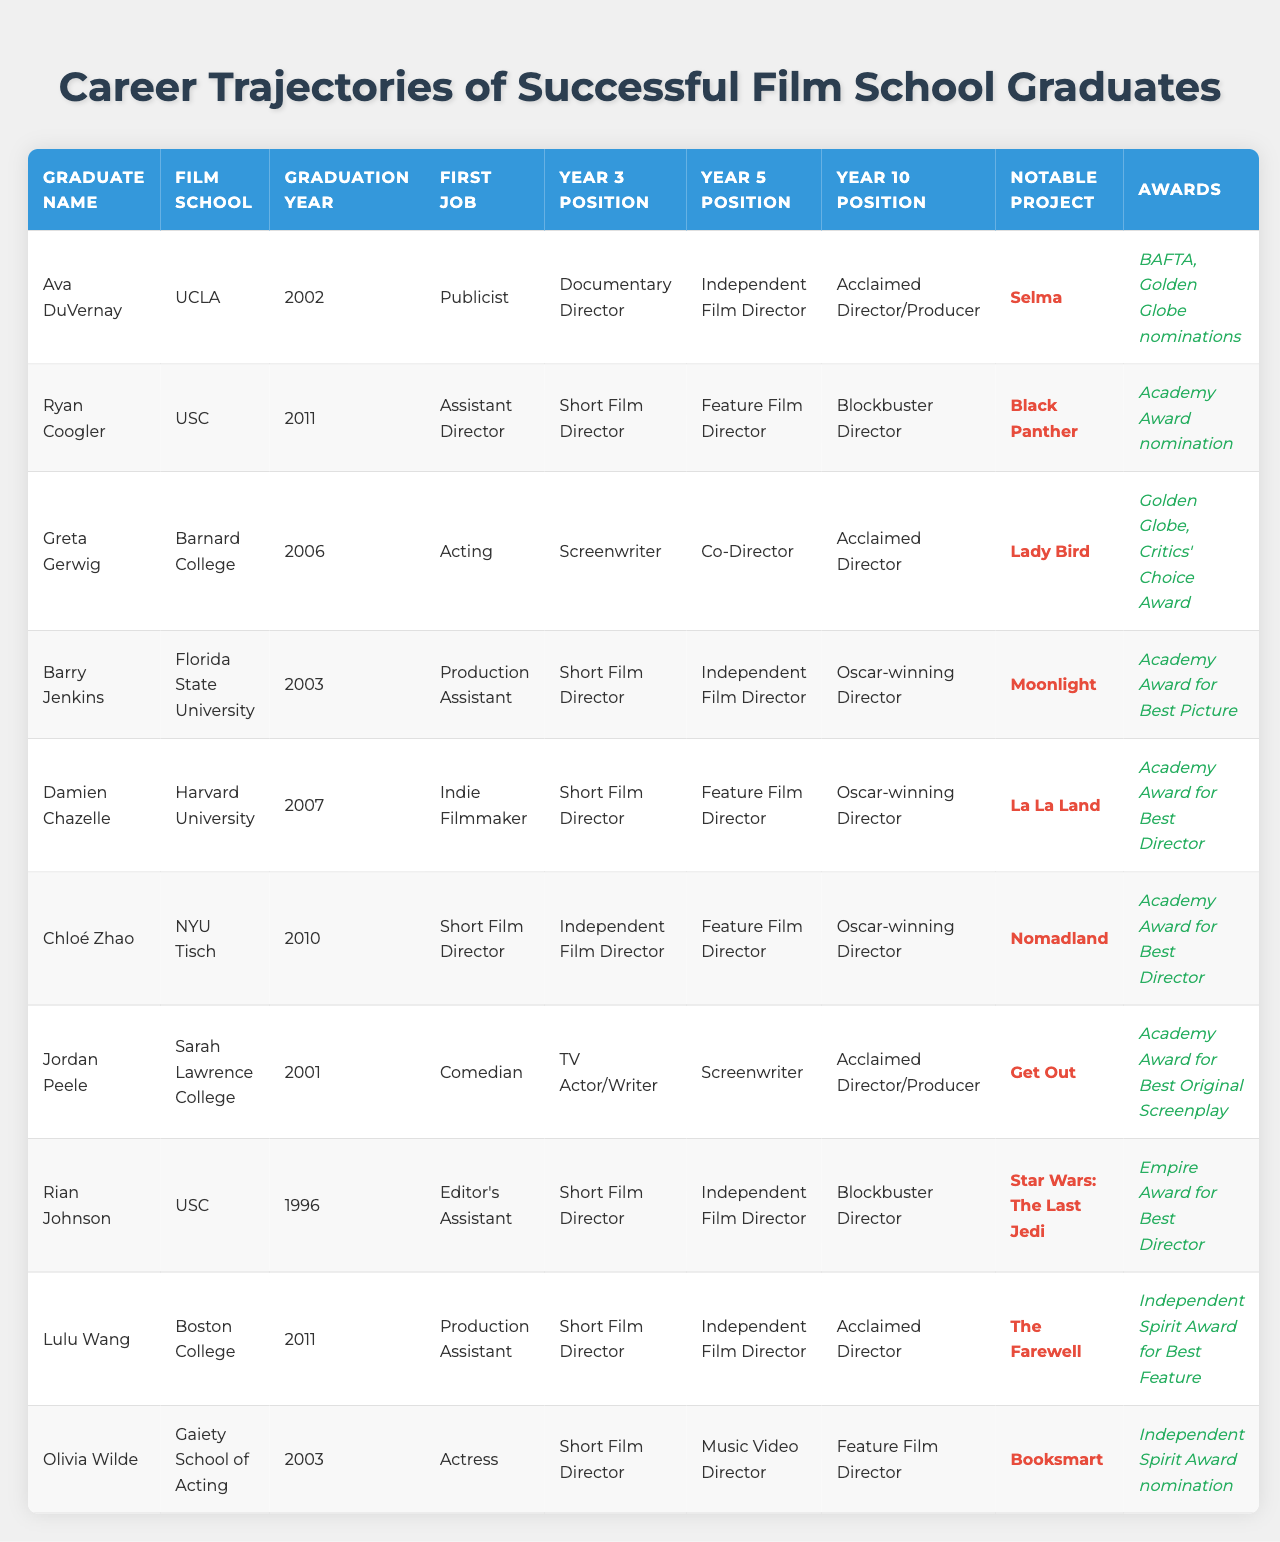What was Ava DuVernay's first job after graduation? Ava DuVernay graduated in 2002 and her first job, according to the table, was as a Publicist.
Answer: Publicist Which film school did Ryan Coogler attend? The table indicates that Ryan Coogler graduated from USC.
Answer: USC What notable project did Greta Gerwig work on? According to the table, Greta Gerwig's notable project is "Lady Bird."
Answer: Lady Bird How many Academy Awards did Barry Jenkins win? The table states that Barry Jenkins won the Academy Award for Best Picture for his film "Moonlight."
Answer: 1 What position did Chloé Zhao hold five years after graduating? The table shows that five years after graduating, Chloé Zhao was a Feature Film Director.
Answer: Feature Film Director Did Jordan Peele win any notable awards? Yes, according to the table, Jordan Peele won the Academy Award for Best Original Screenplay for "Get Out."
Answer: Yes Which graduate had the title of Blockbuster Director at year 10? The table shows that both Ryan Coogler and Rian Johnson held the title of Blockbuster Director at year 10.
Answer: Ryan Coogler and Rian Johnson What is the graduation year of Olivia Wilde? From the table, we can see that Olivia Wilde graduated in 2003.
Answer: 2003 Who transitioned from Acting to Screenwriting by year 3? The table indicates that Greta Gerwig transitioned from Acting to Screenwriting by year 3.
Answer: Greta Gerwig Which graduates became Oscar-winning Directors by year 10? The table lists Barry Jenkins, Damien Chazelle, and Chloé Zhao as graduates who became Oscar-winning Directors by year 10, indicating their successful trajectory.
Answer: Barry Jenkins, Damien Chazelle, Chloé Zhao 